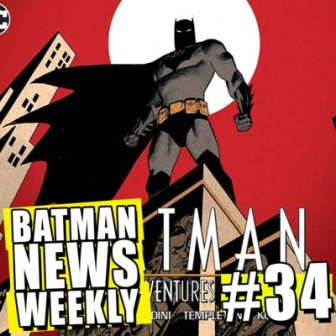Create a brief narrative of the scene taking place on the cover. It’s a tense night in Gotham City. Under the crimson sky, the iconic silhouette of Batman stands vigilant atop a weathered building. Below, sirens wail, and the distant hum of the city's life buzzes. Batman, ever the silent guardian, surveys the streets, his sharp eyes piercing through the night’s secrets. His cape billows, whispering tales of thwarted crimes and battles won. On the cover, this moment freezes—a snapshot of the perpetual watchman ready to swoop in at the first sign of danger, epitomizing the never-ending quest for justice. 